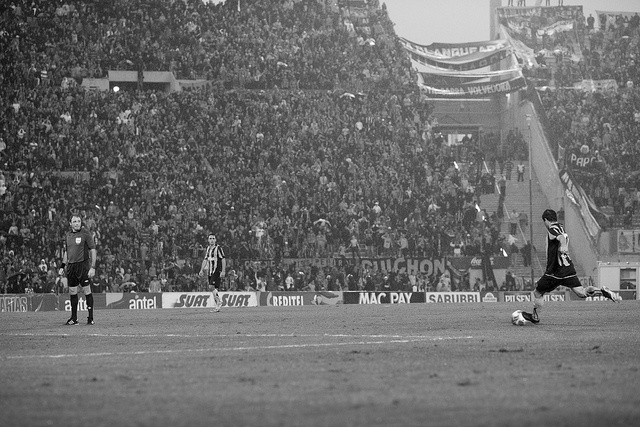Describe the objects in this image and their specific colors. I can see people in gray, black, and lightgray tones, people in black, darkgray, gray, and lightgray tones, people in black, gray, darkgray, and lightgray tones, people in black, darkgray, gray, and lightgray tones, and people in gray and black tones in this image. 